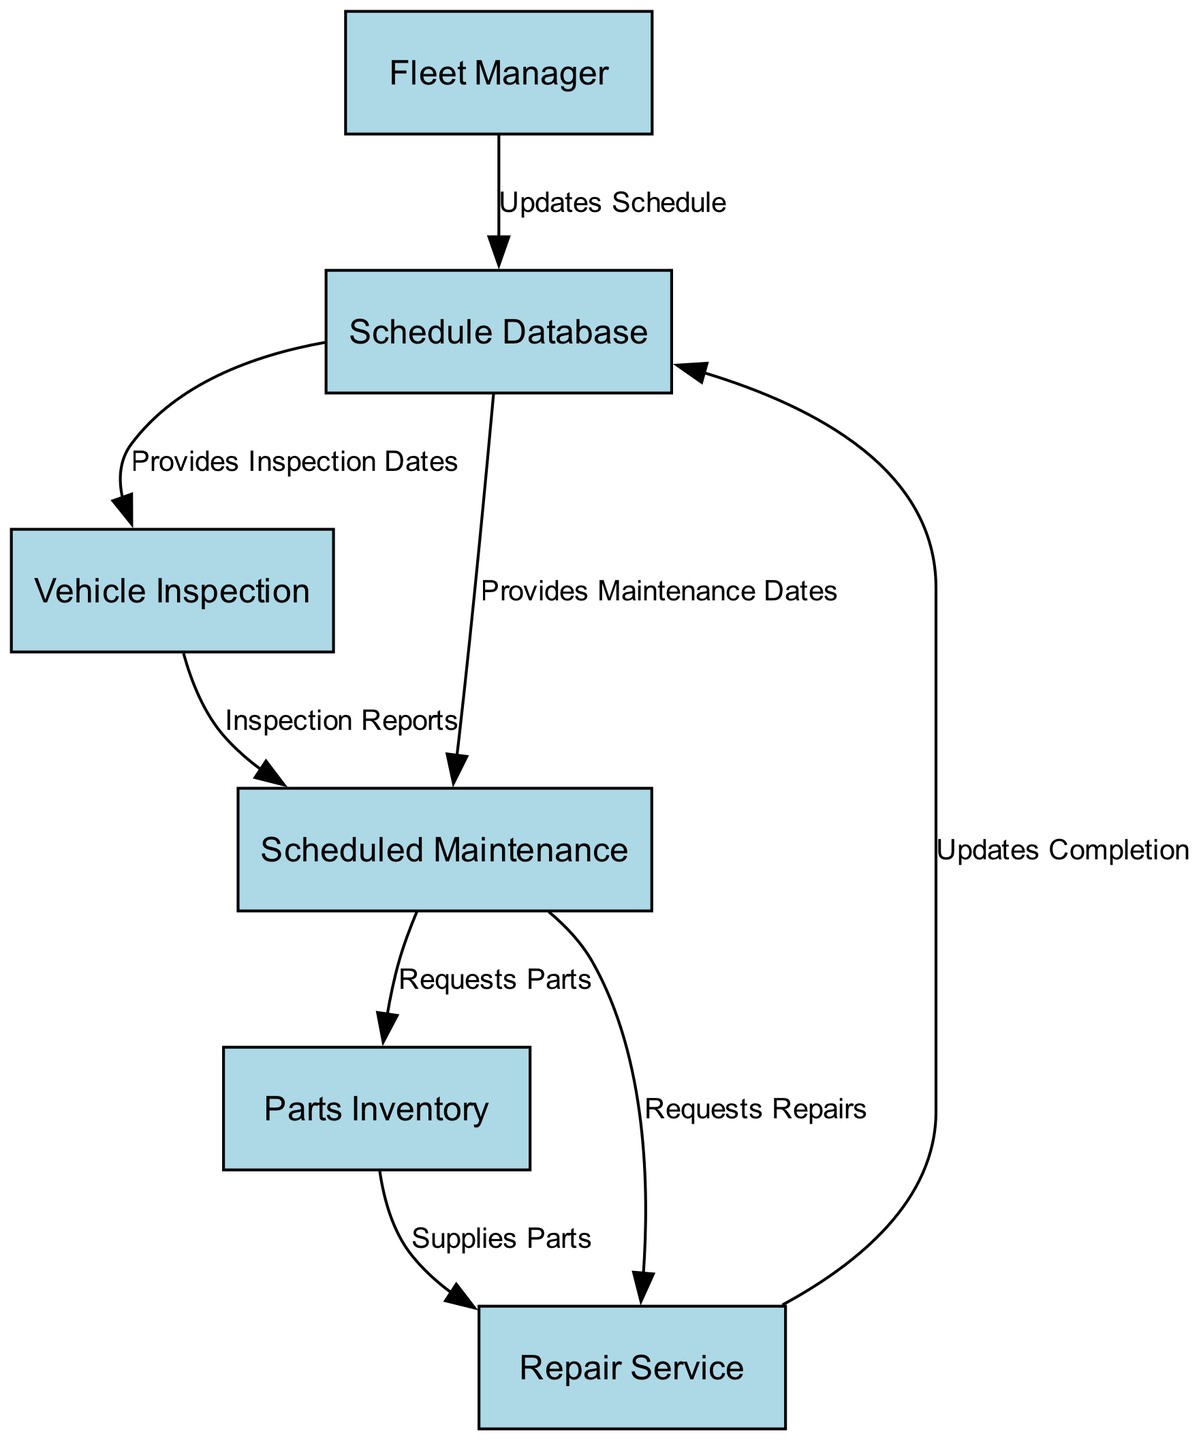What is the label of the first node? The first node has the label "Fleet Manager" as listed in the nodes section of the diagram.
Answer: Fleet Manager How many nodes are there in total? The diagram contains a total of 6 nodes: Fleet Manager, Schedule Database, Vehicle Inspection, Scheduled Maintenance, Parts Inventory, and Repair Service.
Answer: 6 What does the "Schedule Database" provide to "Vehicle Inspection"? The "Schedule Database" provides "Inspection Dates" to "Vehicle Inspection" as indicated by the edge that connects these two nodes.
Answer: Inspection Dates What action does "Scheduled Maintenance" request from "Parts Inventory"? "Scheduled Maintenance" requests "Parts" from "Parts Inventory," according to the edge connecting these two nodes.
Answer: Parts Which node updates completion information back to the "Schedule Database"? The node "Repair Service" updates completion information back to the "Schedule Database" based on the directed edge present in the diagram.
Answer: Repair Service How many edges are there in total? By counting the connections between nodes, the diagram shows a total of 7 edges.
Answer: 7 What is the relationship between "Vehicle Inspection" and "Scheduled Maintenance"? "Vehicle Inspection" provides "Inspection Reports" to "Scheduled Maintenance" as represented by the directed edge between these two nodes.
Answer: Inspection Reports Which node does "Fleet Manager" update? The "Fleet Manager" updates the "Schedule Database," as indicated by the outgoing edge from "Fleet Manager" to "Schedule Database."
Answer: Schedule Database What does "Scheduled Maintenance" request from "Repair Service"? "Scheduled Maintenance" requests "Repairs" from "Repair Service," as noted in the diagram by the corresponding directed edge.
Answer: Repairs What does "Parts Inventory" supply to "Repair Service"? "Parts Inventory" supplies "Parts" to "Repair Service," as illustrated by their connecting edge in the diagram.
Answer: Parts 